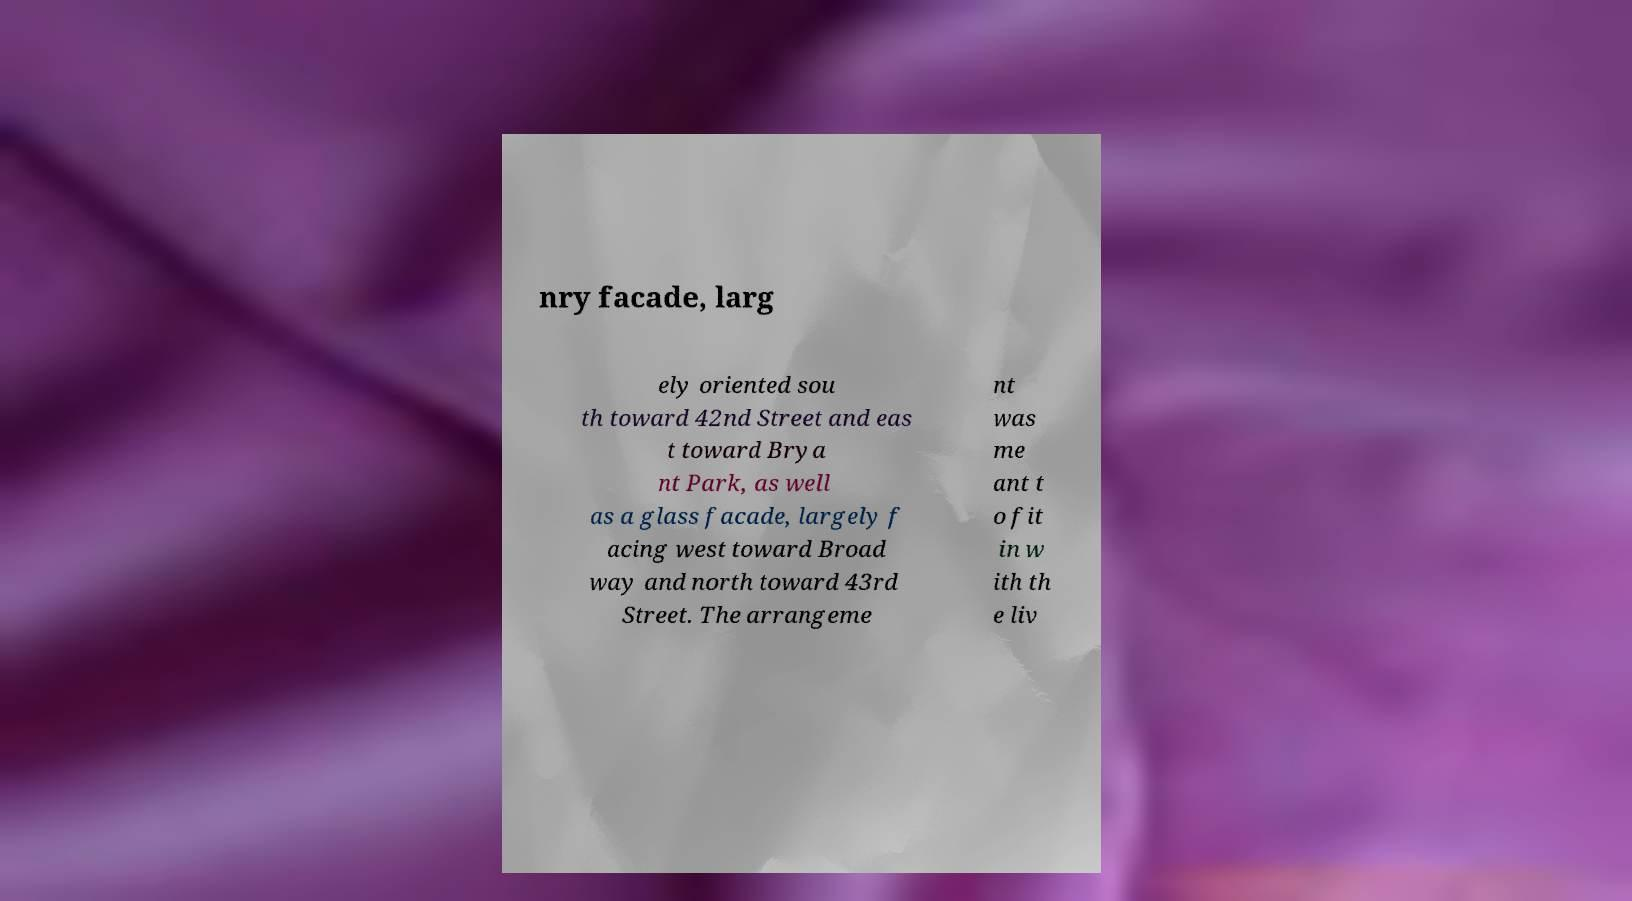Please identify and transcribe the text found in this image. nry facade, larg ely oriented sou th toward 42nd Street and eas t toward Brya nt Park, as well as a glass facade, largely f acing west toward Broad way and north toward 43rd Street. The arrangeme nt was me ant t o fit in w ith th e liv 